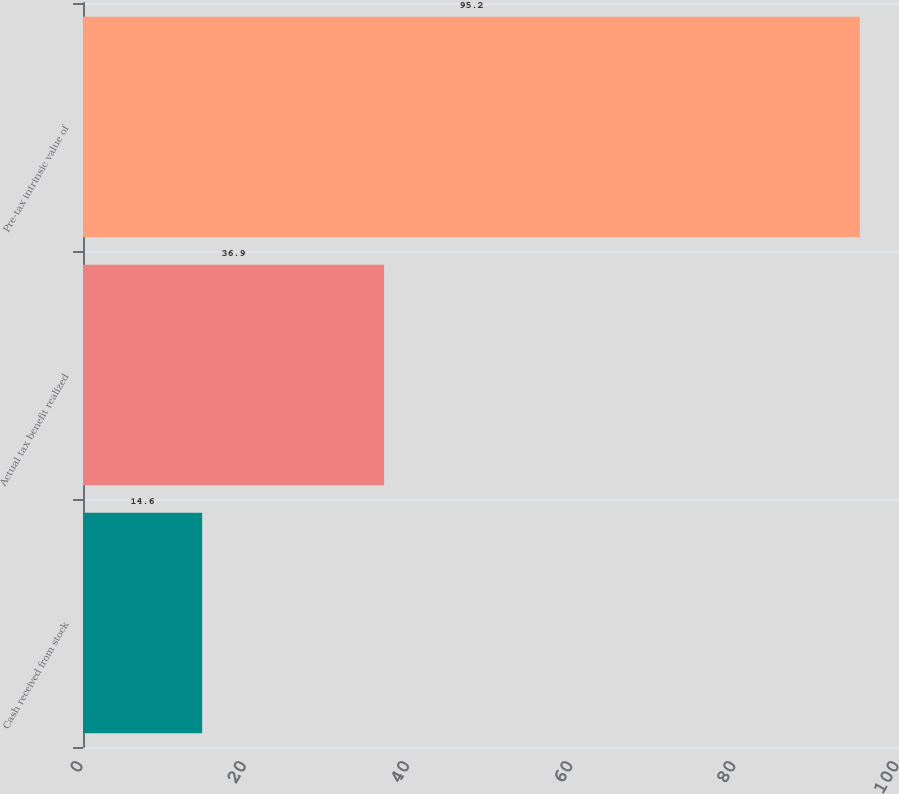<chart> <loc_0><loc_0><loc_500><loc_500><bar_chart><fcel>Cash received from stock<fcel>Actual tax benefit realized<fcel>Pre-tax intrinsic value of<nl><fcel>14.6<fcel>36.9<fcel>95.2<nl></chart> 